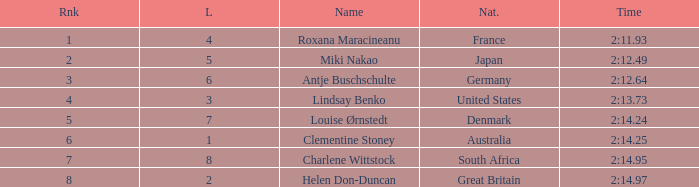What is the average Rank for a lane smaller than 3 with a nationality of Australia? 6.0. 